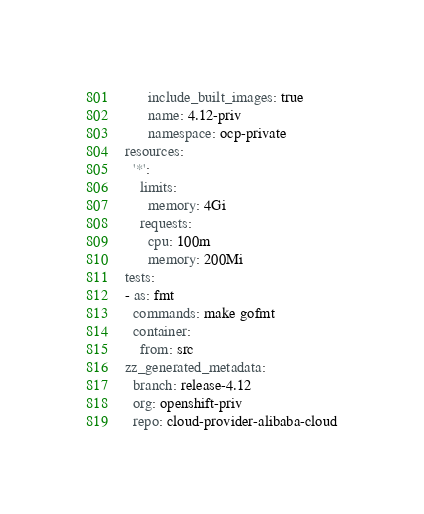<code> <loc_0><loc_0><loc_500><loc_500><_YAML_>      include_built_images: true
      name: 4.12-priv
      namespace: ocp-private
resources:
  '*':
    limits:
      memory: 4Gi
    requests:
      cpu: 100m
      memory: 200Mi
tests:
- as: fmt
  commands: make gofmt
  container:
    from: src
zz_generated_metadata:
  branch: release-4.12
  org: openshift-priv
  repo: cloud-provider-alibaba-cloud
</code> 